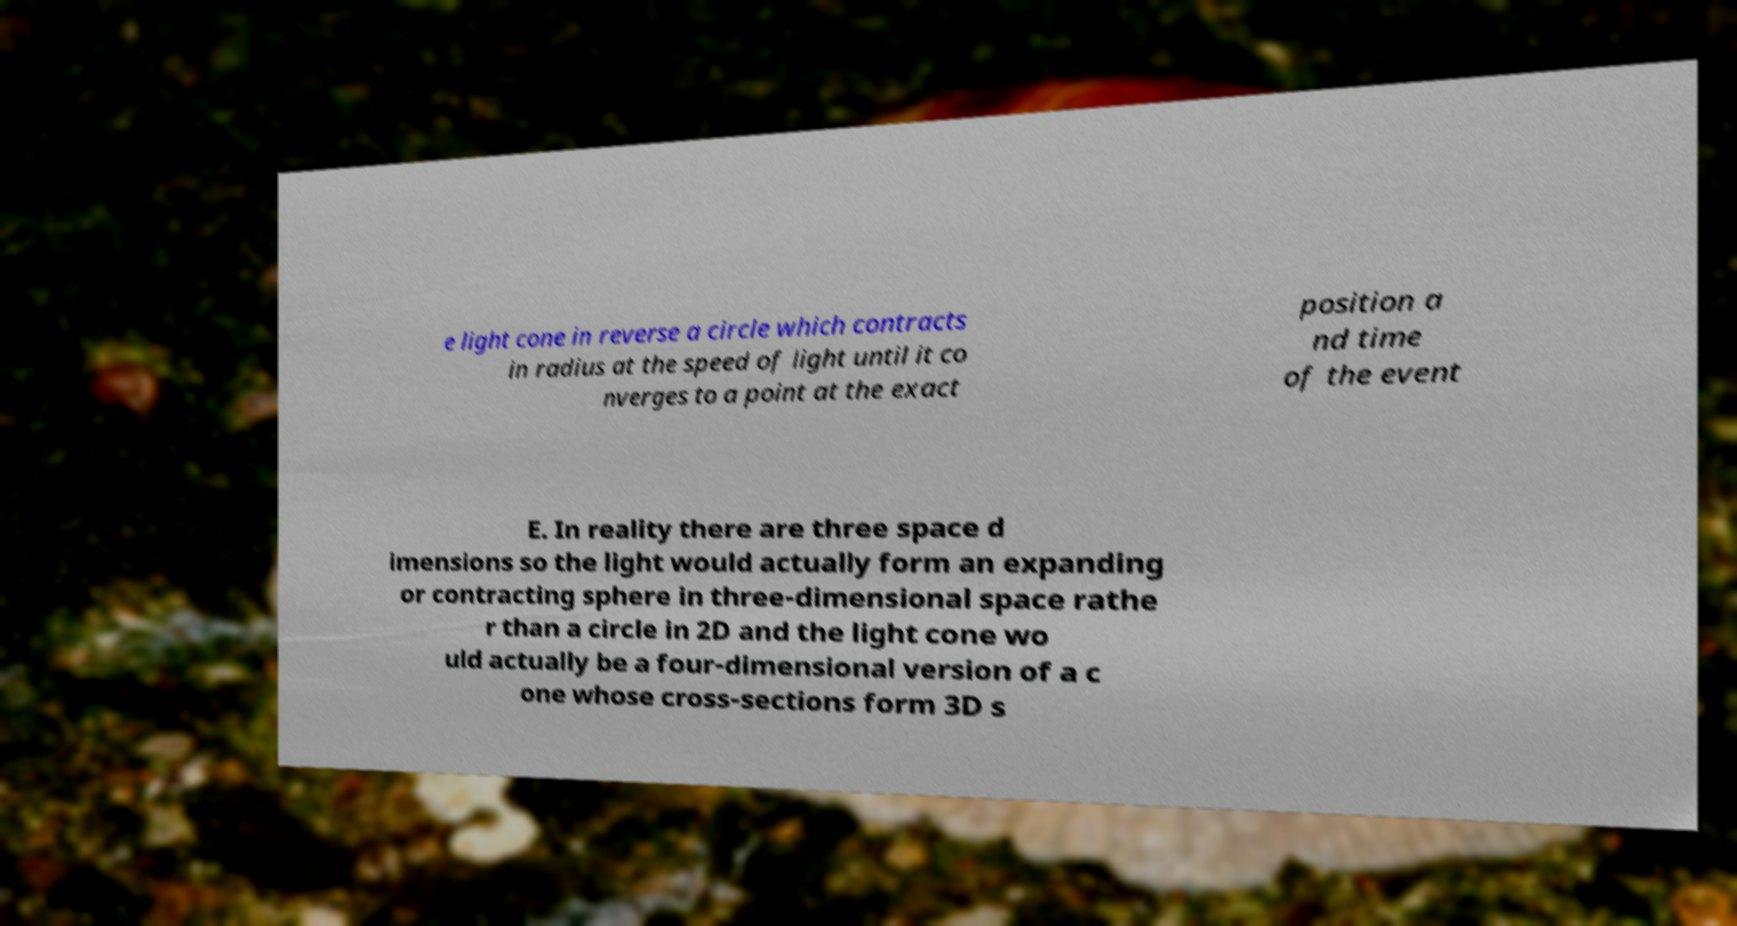Can you accurately transcribe the text from the provided image for me? e light cone in reverse a circle which contracts in radius at the speed of light until it co nverges to a point at the exact position a nd time of the event E. In reality there are three space d imensions so the light would actually form an expanding or contracting sphere in three-dimensional space rathe r than a circle in 2D and the light cone wo uld actually be a four-dimensional version of a c one whose cross-sections form 3D s 